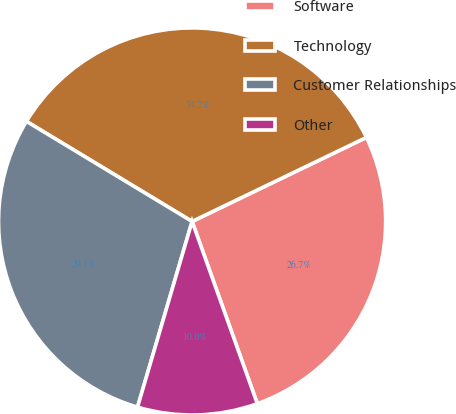Convert chart to OTSL. <chart><loc_0><loc_0><loc_500><loc_500><pie_chart><fcel>Software<fcel>Technology<fcel>Customer Relationships<fcel>Other<nl><fcel>26.68%<fcel>34.2%<fcel>29.1%<fcel>10.02%<nl></chart> 